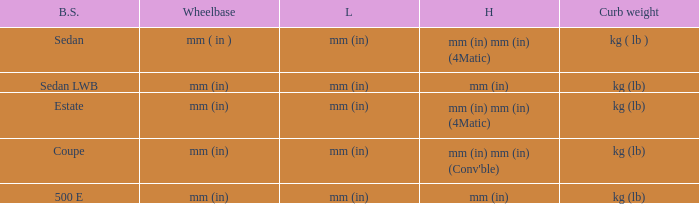What's the length of the model with 500 E body style? Mm (in). 